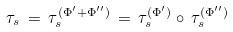Convert formula to latex. <formula><loc_0><loc_0><loc_500><loc_500>\tau _ { s } \, = \, \tau _ { s } ^ { ( \Phi ^ { \prime } + \Phi ^ { \prime \prime } ) } \, = \, \tau _ { s } ^ { ( \Phi ^ { \prime } ) } \circ \, \tau _ { s } ^ { ( \Phi ^ { \prime \prime } ) }</formula> 